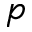<formula> <loc_0><loc_0><loc_500><loc_500>p</formula> 